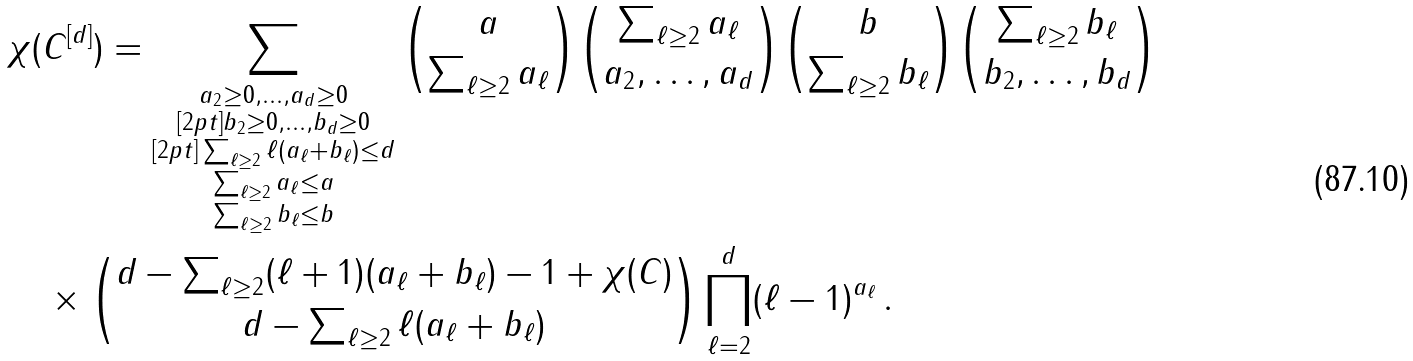<formula> <loc_0><loc_0><loc_500><loc_500>& \chi ( C ^ { [ d ] } ) = \sum _ { \substack { a _ { 2 } \geq 0 , \dots , a _ { d } \geq 0 \\ [ 2 p t ] b _ { 2 } \geq 0 , \dots , b _ { d } \geq 0 \\ [ 2 p t ] \sum _ { \ell \geq 2 } \ell ( a _ { \ell } + b _ { \ell } ) \leq d \\ \sum _ { \ell \geq 2 } a _ { \ell } \leq a \\ \sum _ { \ell \geq 2 } b _ { \ell } \leq b } } \binom { a } { \sum _ { \ell \geq 2 } a _ { \ell } } \binom { \sum _ { \ell \geq 2 } a _ { \ell } } { a _ { 2 } , \dots , a _ { d } } \binom { b } { \sum _ { \ell \geq 2 } b _ { \ell } } \binom { \sum _ { \ell \geq 2 } b _ { \ell } } { b _ { 2 } , \dots , b _ { d } } \\ & \quad \times \binom { d - \sum _ { \ell \geq 2 } ( \ell + 1 ) ( a _ { \ell } + b _ { \ell } ) - 1 + \chi ( C ) } { d - \sum _ { \ell \geq 2 } \ell ( a _ { \ell } + b _ { \ell } ) } \prod _ { \ell = 2 } ^ { d } ( \ell - 1 ) ^ { a _ { \ell } } \, .</formula> 